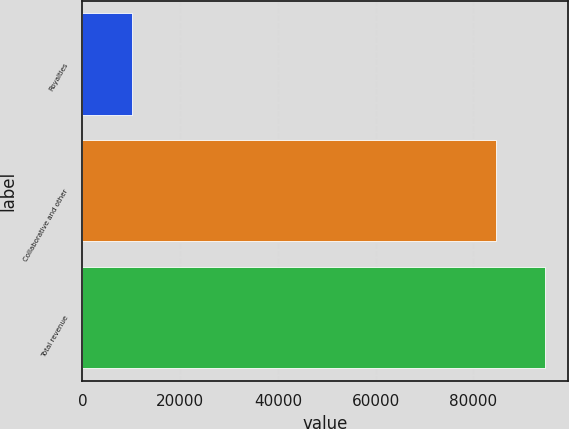Convert chart. <chart><loc_0><loc_0><loc_500><loc_500><bar_chart><fcel>Royalties<fcel>Collaborative and other<fcel>Total revenue<nl><fcel>10054<fcel>84716<fcel>94770<nl></chart> 